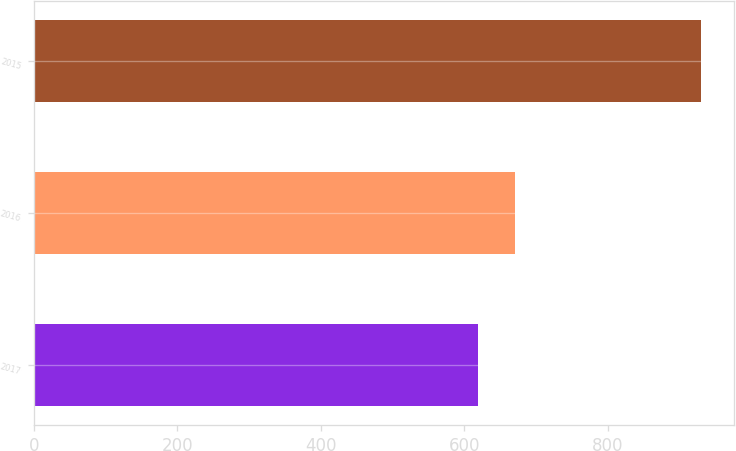Convert chart to OTSL. <chart><loc_0><loc_0><loc_500><loc_500><bar_chart><fcel>2017<fcel>2016<fcel>2015<nl><fcel>619.5<fcel>670.8<fcel>929.4<nl></chart> 